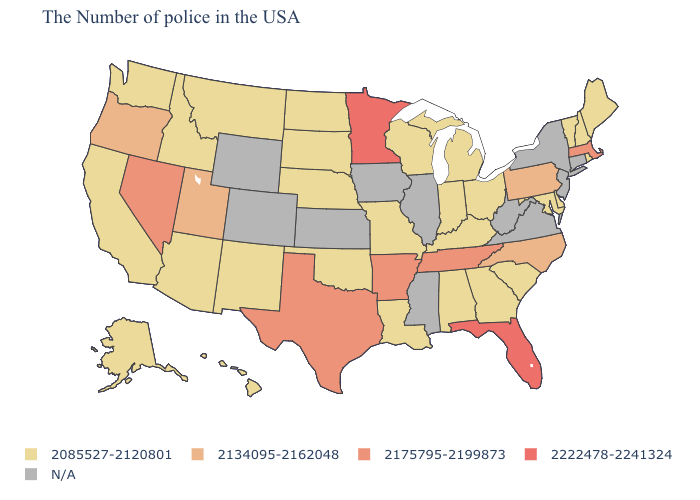Does the first symbol in the legend represent the smallest category?
Be succinct. Yes. Name the states that have a value in the range 2134095-2162048?
Give a very brief answer. Pennsylvania, North Carolina, Utah, Oregon. Name the states that have a value in the range 2175795-2199873?
Keep it brief. Massachusetts, Tennessee, Arkansas, Texas, Nevada. What is the value of New York?
Be succinct. N/A. Does the first symbol in the legend represent the smallest category?
Concise answer only. Yes. What is the value of Texas?
Keep it brief. 2175795-2199873. Name the states that have a value in the range 2085527-2120801?
Short answer required. Maine, Rhode Island, New Hampshire, Vermont, Delaware, Maryland, South Carolina, Ohio, Georgia, Michigan, Kentucky, Indiana, Alabama, Wisconsin, Louisiana, Missouri, Nebraska, Oklahoma, South Dakota, North Dakota, New Mexico, Montana, Arizona, Idaho, California, Washington, Alaska, Hawaii. Does the map have missing data?
Quick response, please. Yes. What is the lowest value in states that border Mississippi?
Give a very brief answer. 2085527-2120801. Name the states that have a value in the range 2175795-2199873?
Keep it brief. Massachusetts, Tennessee, Arkansas, Texas, Nevada. Name the states that have a value in the range N/A?
Quick response, please. Connecticut, New York, New Jersey, Virginia, West Virginia, Illinois, Mississippi, Iowa, Kansas, Wyoming, Colorado. Which states have the lowest value in the MidWest?
Write a very short answer. Ohio, Michigan, Indiana, Wisconsin, Missouri, Nebraska, South Dakota, North Dakota. What is the lowest value in the South?
Write a very short answer. 2085527-2120801. Name the states that have a value in the range 2175795-2199873?
Concise answer only. Massachusetts, Tennessee, Arkansas, Texas, Nevada. 